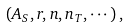<formula> <loc_0><loc_0><loc_500><loc_500>( A _ { S } , r , n , n _ { T } , \cdots ) \, ,</formula> 